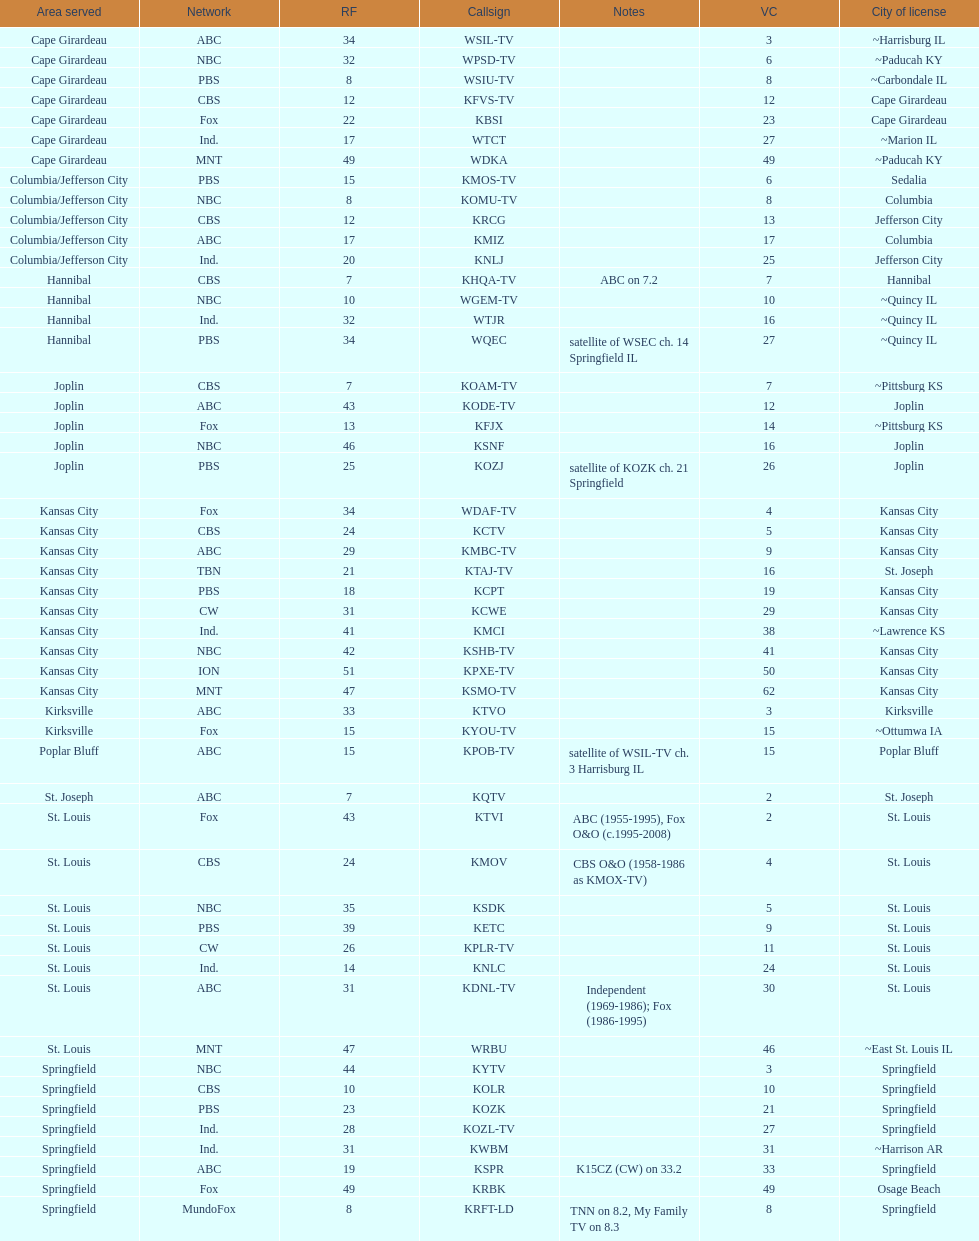Could you parse the entire table as a dict? {'header': ['Area served', 'Network', 'RF', 'Callsign', 'Notes', 'VC', 'City of license'], 'rows': [['Cape Girardeau', 'ABC', '34', 'WSIL-TV', '', '3', '~Harrisburg IL'], ['Cape Girardeau', 'NBC', '32', 'WPSD-TV', '', '6', '~Paducah KY'], ['Cape Girardeau', 'PBS', '8', 'WSIU-TV', '', '8', '~Carbondale IL'], ['Cape Girardeau', 'CBS', '12', 'KFVS-TV', '', '12', 'Cape Girardeau'], ['Cape Girardeau', 'Fox', '22', 'KBSI', '', '23', 'Cape Girardeau'], ['Cape Girardeau', 'Ind.', '17', 'WTCT', '', '27', '~Marion IL'], ['Cape Girardeau', 'MNT', '49', 'WDKA', '', '49', '~Paducah KY'], ['Columbia/Jefferson City', 'PBS', '15', 'KMOS-TV', '', '6', 'Sedalia'], ['Columbia/Jefferson City', 'NBC', '8', 'KOMU-TV', '', '8', 'Columbia'], ['Columbia/Jefferson City', 'CBS', '12', 'KRCG', '', '13', 'Jefferson City'], ['Columbia/Jefferson City', 'ABC', '17', 'KMIZ', '', '17', 'Columbia'], ['Columbia/Jefferson City', 'Ind.', '20', 'KNLJ', '', '25', 'Jefferson City'], ['Hannibal', 'CBS', '7', 'KHQA-TV', 'ABC on 7.2', '7', 'Hannibal'], ['Hannibal', 'NBC', '10', 'WGEM-TV', '', '10', '~Quincy IL'], ['Hannibal', 'Ind.', '32', 'WTJR', '', '16', '~Quincy IL'], ['Hannibal', 'PBS', '34', 'WQEC', 'satellite of WSEC ch. 14 Springfield IL', '27', '~Quincy IL'], ['Joplin', 'CBS', '7', 'KOAM-TV', '', '7', '~Pittsburg KS'], ['Joplin', 'ABC', '43', 'KODE-TV', '', '12', 'Joplin'], ['Joplin', 'Fox', '13', 'KFJX', '', '14', '~Pittsburg KS'], ['Joplin', 'NBC', '46', 'KSNF', '', '16', 'Joplin'], ['Joplin', 'PBS', '25', 'KOZJ', 'satellite of KOZK ch. 21 Springfield', '26', 'Joplin'], ['Kansas City', 'Fox', '34', 'WDAF-TV', '', '4', 'Kansas City'], ['Kansas City', 'CBS', '24', 'KCTV', '', '5', 'Kansas City'], ['Kansas City', 'ABC', '29', 'KMBC-TV', '', '9', 'Kansas City'], ['Kansas City', 'TBN', '21', 'KTAJ-TV', '', '16', 'St. Joseph'], ['Kansas City', 'PBS', '18', 'KCPT', '', '19', 'Kansas City'], ['Kansas City', 'CW', '31', 'KCWE', '', '29', 'Kansas City'], ['Kansas City', 'Ind.', '41', 'KMCI', '', '38', '~Lawrence KS'], ['Kansas City', 'NBC', '42', 'KSHB-TV', '', '41', 'Kansas City'], ['Kansas City', 'ION', '51', 'KPXE-TV', '', '50', 'Kansas City'], ['Kansas City', 'MNT', '47', 'KSMO-TV', '', '62', 'Kansas City'], ['Kirksville', 'ABC', '33', 'KTVO', '', '3', 'Kirksville'], ['Kirksville', 'Fox', '15', 'KYOU-TV', '', '15', '~Ottumwa IA'], ['Poplar Bluff', 'ABC', '15', 'KPOB-TV', 'satellite of WSIL-TV ch. 3 Harrisburg IL', '15', 'Poplar Bluff'], ['St. Joseph', 'ABC', '7', 'KQTV', '', '2', 'St. Joseph'], ['St. Louis', 'Fox', '43', 'KTVI', 'ABC (1955-1995), Fox O&O (c.1995-2008)', '2', 'St. Louis'], ['St. Louis', 'CBS', '24', 'KMOV', 'CBS O&O (1958-1986 as KMOX-TV)', '4', 'St. Louis'], ['St. Louis', 'NBC', '35', 'KSDK', '', '5', 'St. Louis'], ['St. Louis', 'PBS', '39', 'KETC', '', '9', 'St. Louis'], ['St. Louis', 'CW', '26', 'KPLR-TV', '', '11', 'St. Louis'], ['St. Louis', 'Ind.', '14', 'KNLC', '', '24', 'St. Louis'], ['St. Louis', 'ABC', '31', 'KDNL-TV', 'Independent (1969-1986); Fox (1986-1995)', '30', 'St. Louis'], ['St. Louis', 'MNT', '47', 'WRBU', '', '46', '~East St. Louis IL'], ['Springfield', 'NBC', '44', 'KYTV', '', '3', 'Springfield'], ['Springfield', 'CBS', '10', 'KOLR', '', '10', 'Springfield'], ['Springfield', 'PBS', '23', 'KOZK', '', '21', 'Springfield'], ['Springfield', 'Ind.', '28', 'KOZL-TV', '', '27', 'Springfield'], ['Springfield', 'Ind.', '31', 'KWBM', '', '31', '~Harrison AR'], ['Springfield', 'ABC', '19', 'KSPR', 'K15CZ (CW) on 33.2', '33', 'Springfield'], ['Springfield', 'Fox', '49', 'KRBK', '', '49', 'Osage Beach'], ['Springfield', 'MundoFox', '8', 'KRFT-LD', 'TNN on 8.2, My Family TV on 8.3', '8', 'Springfield']]} How many television stations serve the cape girardeau area? 7. 